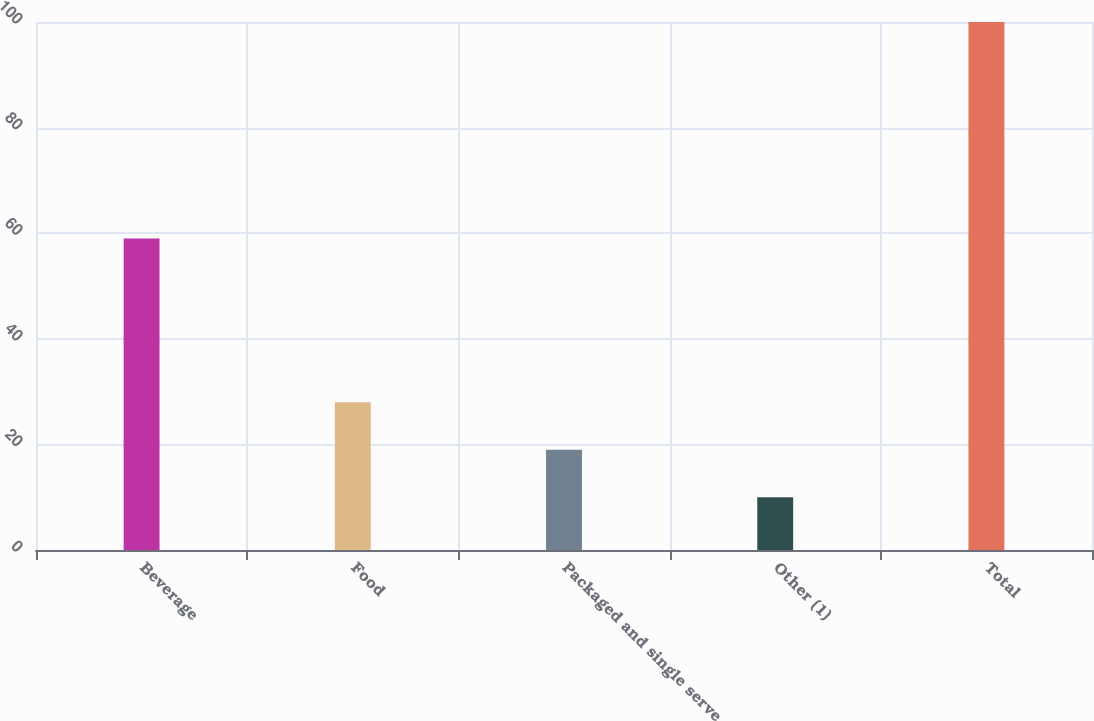<chart> <loc_0><loc_0><loc_500><loc_500><bar_chart><fcel>Beverage<fcel>Food<fcel>Packaged and single serve<fcel>Other (1)<fcel>Total<nl><fcel>59<fcel>28<fcel>19<fcel>10<fcel>100<nl></chart> 